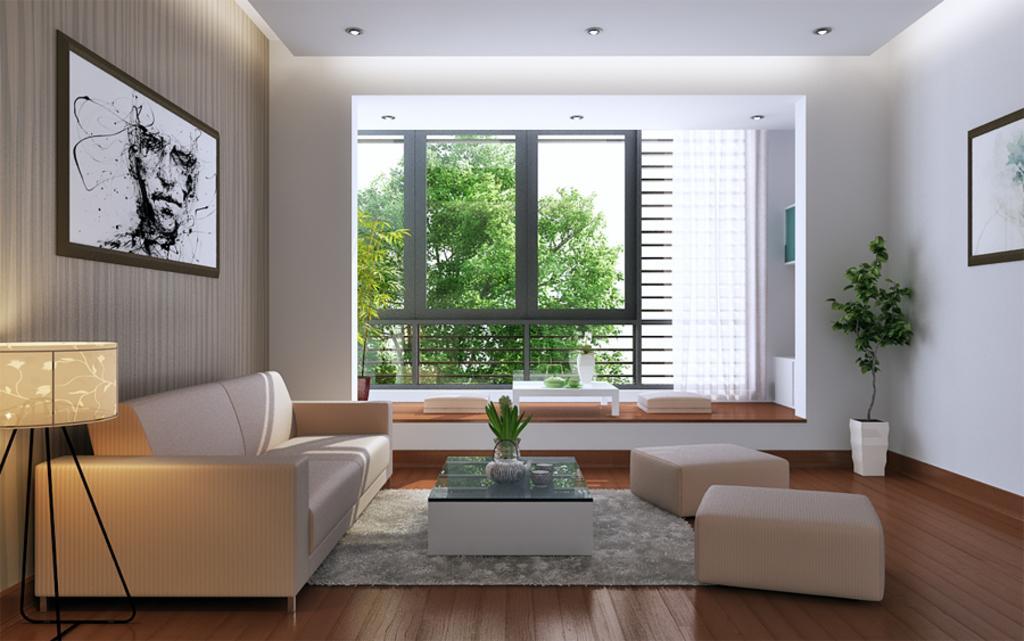Describe this image in one or two sentences. In this picture we can see the inside view of a building. This is sofa. There is a table. Here we can see a plant and this is wall. And there are frames. On the background there are trees and this is glass. 